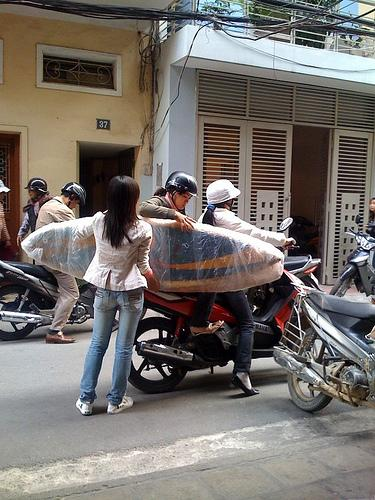What is the cellophane wrapping applied over top of? surfboard 